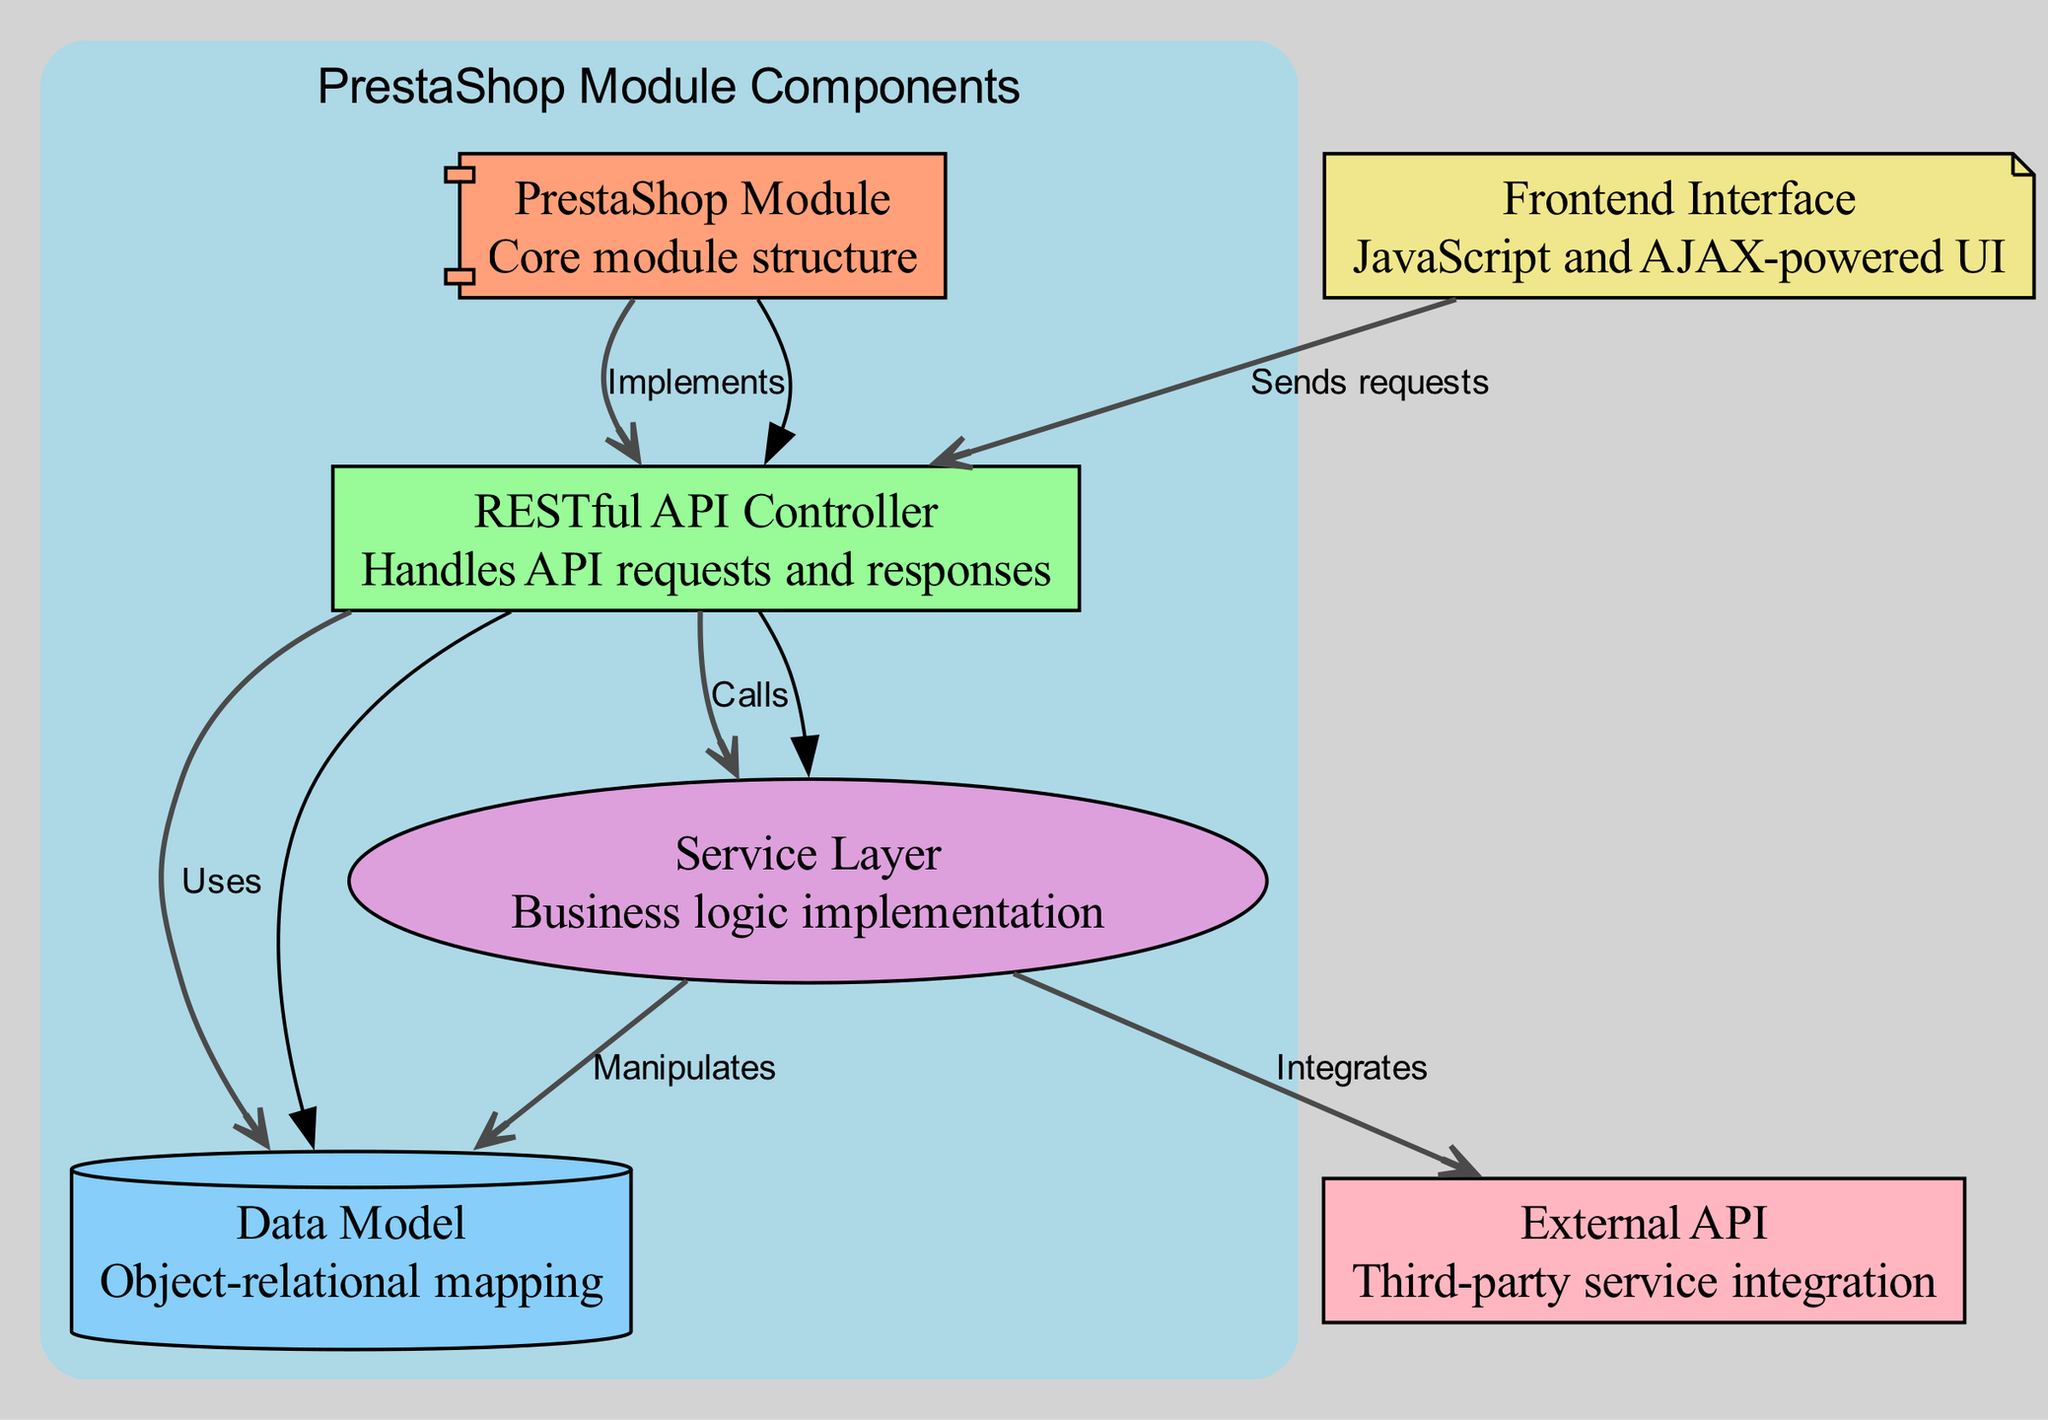What are the names of the nodes in this diagram? The diagram includes six nodes: PrestaShop Module, RESTful API Controller, Data Model, Service Layer, Frontend Interface, and External API.
Answer: PrestaShop Module, RESTful API Controller, Data Model, Service Layer, Frontend Interface, External API How many edges are present in the diagram? By counting the connections (edges) between nodes, there are six edges in total, indicating various relationships between the components.
Answer: 6 Which node implements the RESTful API Controller? The edge labeled "Implements" shows a direct connection from the PrestaShop Module to the RESTful API Controller, indicating that the module is the one implementing the controller.
Answer: PrestaShop Module What does the Frontend Interface do in relation to the RESTful API Controller? The edge labeled "Sends requests" illustrates that the Frontend Interface communicates with the RESTful API Controller by sending API requests from the user interface.
Answer: Sends requests Which component manipulates the Data Model? The edge labeled "Manipulates" shows a connection from the Service Layer to the Data Model, indicating that the Service Layer performs operations on the data.
Answer: Service Layer What does the RESTful API Controller use? The edge labeled "Uses" connects the RESTful API Controller to the Data Model, suggesting that it requires the Data Model for handling data-related operations in response to API requests.
Answer: Data Model How does the Service Layer interact with the External API? The edge labeled "Integrates" demonstrates a direct relationship where the Service Layer integrates with the External API to utilize third-party services in its business logic.
Answer: Integrates Which two components are directly connected by the label "Calls"? The edge labeled "Calls" connects the RESTful API Controller to the Service Layer, indicating that the controller calls methods or functions provided by the Service Layer to process requests.
Answer: RESTful API Controller and Service Layer Which node represents the core structure of the module and what is its color? The node labeled "PrestaShop Module" represents the core structure and is shown in a coral color (#FFA07A) in the diagram.
Answer: Coral (#FFA07A) 